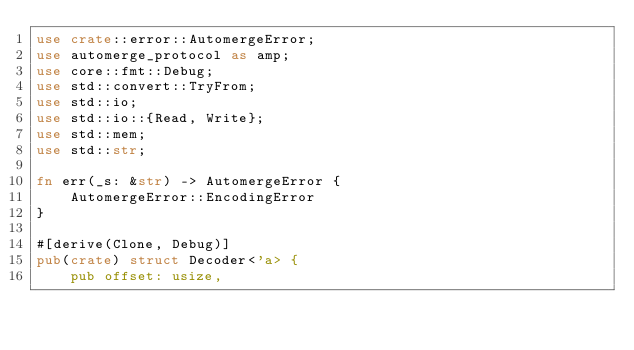Convert code to text. <code><loc_0><loc_0><loc_500><loc_500><_Rust_>use crate::error::AutomergeError;
use automerge_protocol as amp;
use core::fmt::Debug;
use std::convert::TryFrom;
use std::io;
use std::io::{Read, Write};
use std::mem;
use std::str;

fn err(_s: &str) -> AutomergeError {
    AutomergeError::EncodingError
}

#[derive(Clone, Debug)]
pub(crate) struct Decoder<'a> {
    pub offset: usize,</code> 